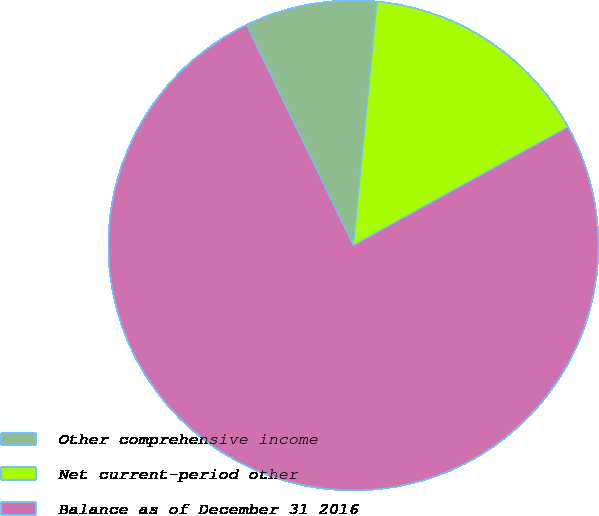Convert chart to OTSL. <chart><loc_0><loc_0><loc_500><loc_500><pie_chart><fcel>Other comprehensive income<fcel>Net current-period other<fcel>Balance as of December 31 2016<nl><fcel>8.72%<fcel>15.43%<fcel>75.85%<nl></chart> 